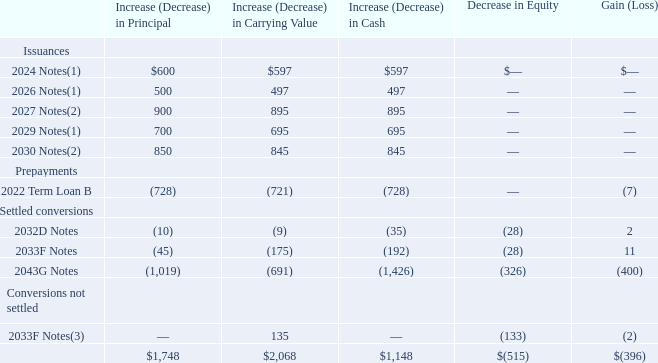Debt Activity
The table below presents the effects of issuances, prepayments, and conversions of debt in 2019. When we receive a notice of conversion for any of our convertible notes and elect to settle in cash any amount of the conversion obligation in excess of the principal amount, the cash settlement obligations become derivative debt liabilities subject to mark-to-market accounting treatment based on the volume-weighted-average price of our common stock over a period of 20 consecutive trading days. Accordingly, at the date of our election to settle a conversion in cash, we reclassify the fair value of the equity component of the converted notes from additional capital to derivative debt liability within current debt in our consolidated balance sheet.
In 2018, we repurchased or redeemed $6.96 billion of principal amount of notes (carrying value of $6.93 billion) for an aggregate of $9.42 billion in cash and 4 million shares of our treasury stock. As of August 30, 2018, an aggregate of $35 million principal amount of our 2033F Notes (with a carrying value of $165 million) had converted but not settled. These notes settled in 2019 for $153 million in cash and the effect of the settlement is included in the table above. In connection with these transactions, we recognized aggregate non-operating losses of $385 million in 2018.
In 2017, we repurchased or redeemed $1.55 billion of principal amount of notes (carrying value of $1.54 billion) for an aggregate of $1.63 billion in cash. In connection with these transactions, we recognized aggregate non-operating losses of $94 million in 2017.
(1)  Issued February 6, 2019.
(2)  Issued July 12, 2019.
(3)  As of August 29, 2019, an aggregate of $44 million principal amount of our 2033F Notes (with a carrying value of $179 million) had converted but not settled. These notes settled in the first quarter of 2020 for $192 million in cash.
How much principal amount of notes did the company repurchased or redeemed in 2018? $6.96 billion. What was the difference in its carrying value of the issuance of 2027 Notes? 895. What was the decrease in equity of settled conversions in 2032D Notes? (28). What was the total value of the changes in principal on the issuance of 2024 Notes, 2026 Notes, 2027 Notes, 2029 Notes, and 2030 Notes? 600+500+900+700+850
Answer: 3550. What is the ratio of the increase in carrying value of 2029 Notes to 2030 Notes? 695/845 
Answer: 0.82. What is the difference of increase in cash between 2024 Notes and 2026 Notes? 597 - 497 
Answer: 100. 